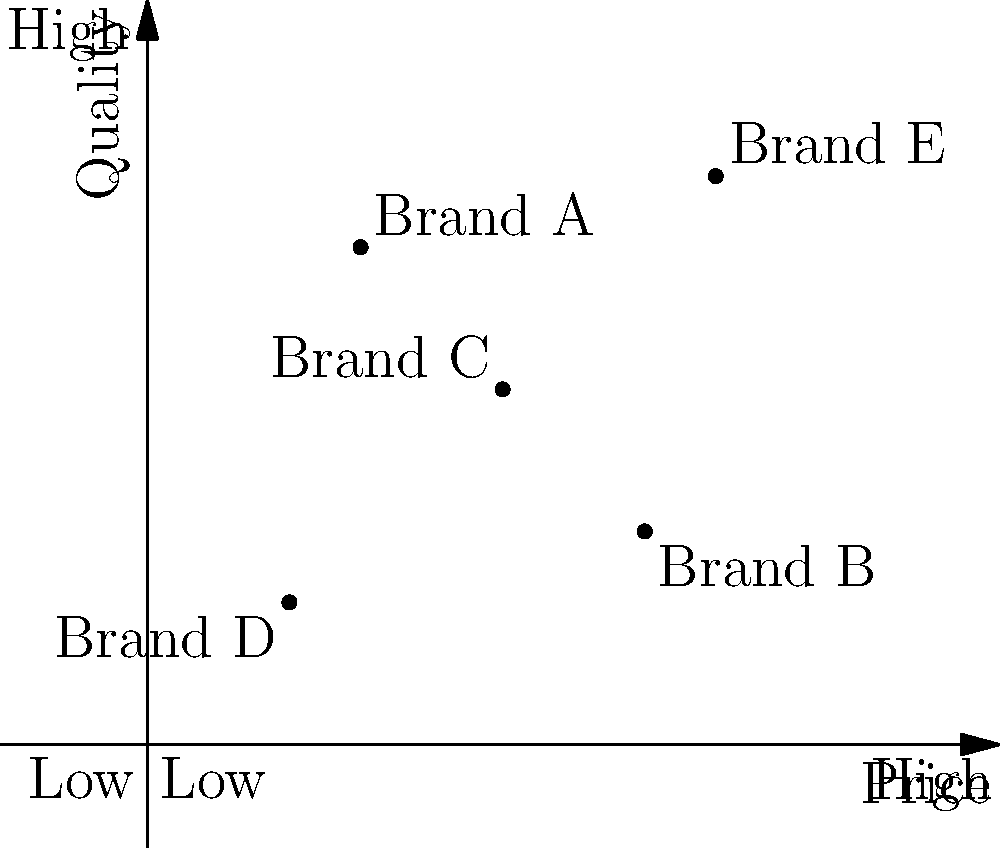As a marketing professional, you've been asked to analyze the positioning of various brands in the market. Based on the perceptual map provided, which brand would you recommend to a customer looking for a high-quality product without considering price sensitivity? To answer this question, we need to analyze the perceptual map and understand the positioning of each brand:

1. The perceptual map shows two dimensions: Price (x-axis) and Quality (y-axis).
2. Both axes range from Low to High.
3. There are five brands plotted on the map: A, B, C, D, and E.

Let's examine each brand's position:

- Brand A: Relatively low price, high quality
- Brand B: High price, relatively low quality
- Brand C: Medium price, medium quality
- Brand D: Low price, low quality
- Brand E: High price, high quality

The question asks for a high-quality product without considering price sensitivity. This means we should focus solely on the quality dimension (y-axis).

Looking at the vertical positions of the brands:
- Brand E is positioned highest on the quality axis
- Brand A is the second-highest in terms of quality
- Brand C is in the middle
- Brands B and D are lower in quality

Therefore, if we're recommending a product based solely on quality without considering price, Brand E would be the best choice as it is positioned highest on the quality axis.
Answer: Brand E 